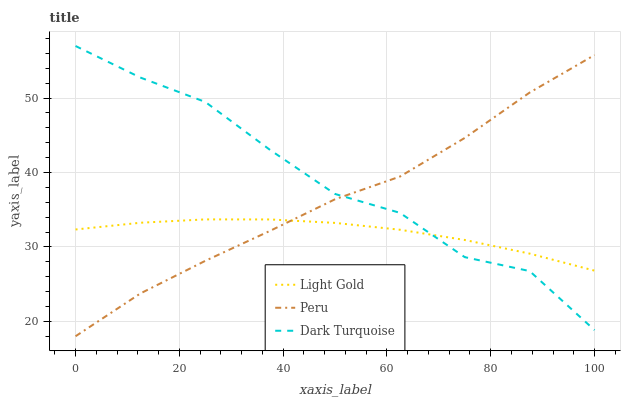Does Light Gold have the minimum area under the curve?
Answer yes or no. Yes. Does Dark Turquoise have the maximum area under the curve?
Answer yes or no. Yes. Does Peru have the minimum area under the curve?
Answer yes or no. No. Does Peru have the maximum area under the curve?
Answer yes or no. No. Is Light Gold the smoothest?
Answer yes or no. Yes. Is Dark Turquoise the roughest?
Answer yes or no. Yes. Is Peru the smoothest?
Answer yes or no. No. Is Peru the roughest?
Answer yes or no. No. Does Peru have the lowest value?
Answer yes or no. Yes. Does Light Gold have the lowest value?
Answer yes or no. No. Does Dark Turquoise have the highest value?
Answer yes or no. Yes. Does Peru have the highest value?
Answer yes or no. No. Does Light Gold intersect Dark Turquoise?
Answer yes or no. Yes. Is Light Gold less than Dark Turquoise?
Answer yes or no. No. Is Light Gold greater than Dark Turquoise?
Answer yes or no. No. 